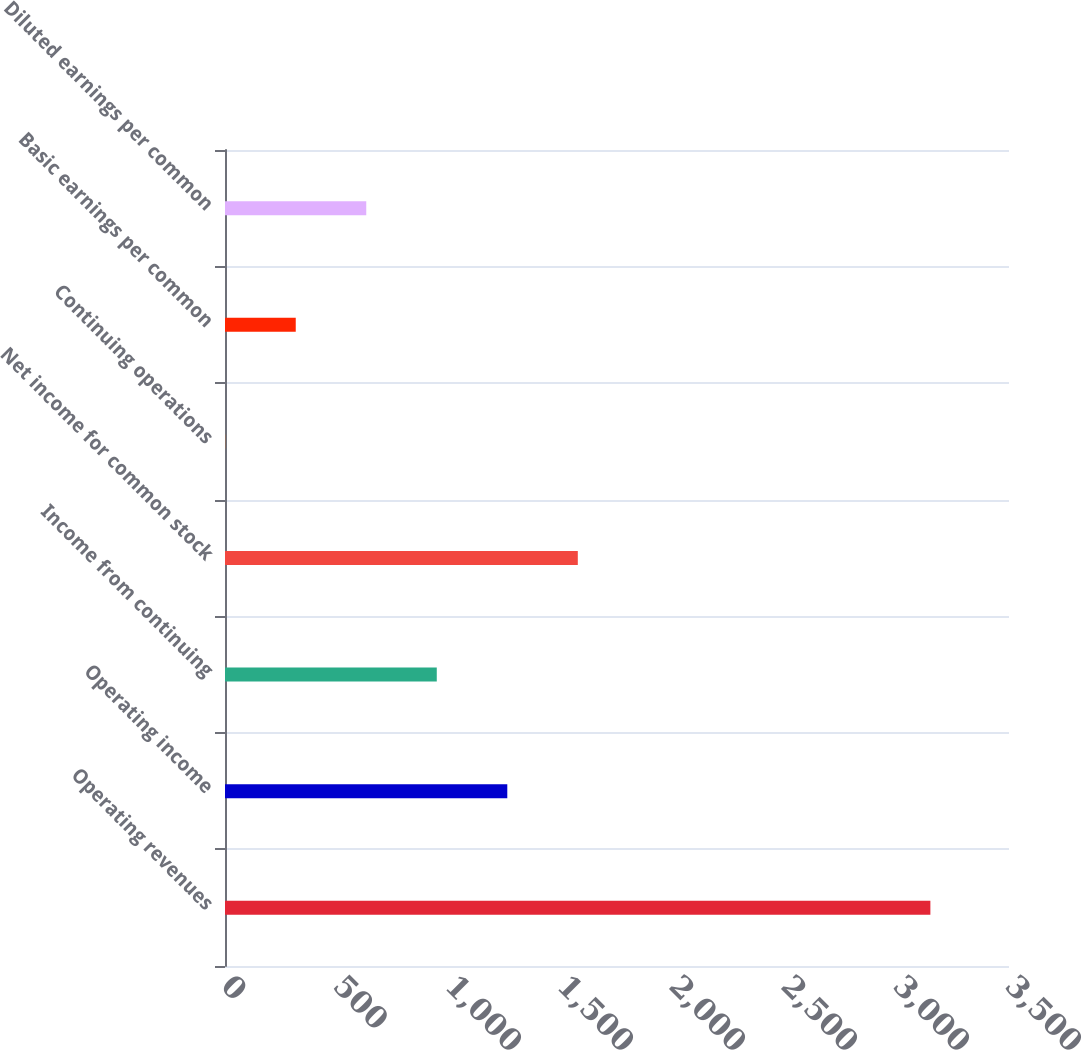<chart> <loc_0><loc_0><loc_500><loc_500><bar_chart><fcel>Operating revenues<fcel>Operating income<fcel>Income from continuing<fcel>Net income for common stock<fcel>Continuing operations<fcel>Basic earnings per common<fcel>Diluted earnings per common<nl><fcel>3149<fcel>1260.23<fcel>945.43<fcel>1575.03<fcel>1.03<fcel>315.83<fcel>630.63<nl></chart> 